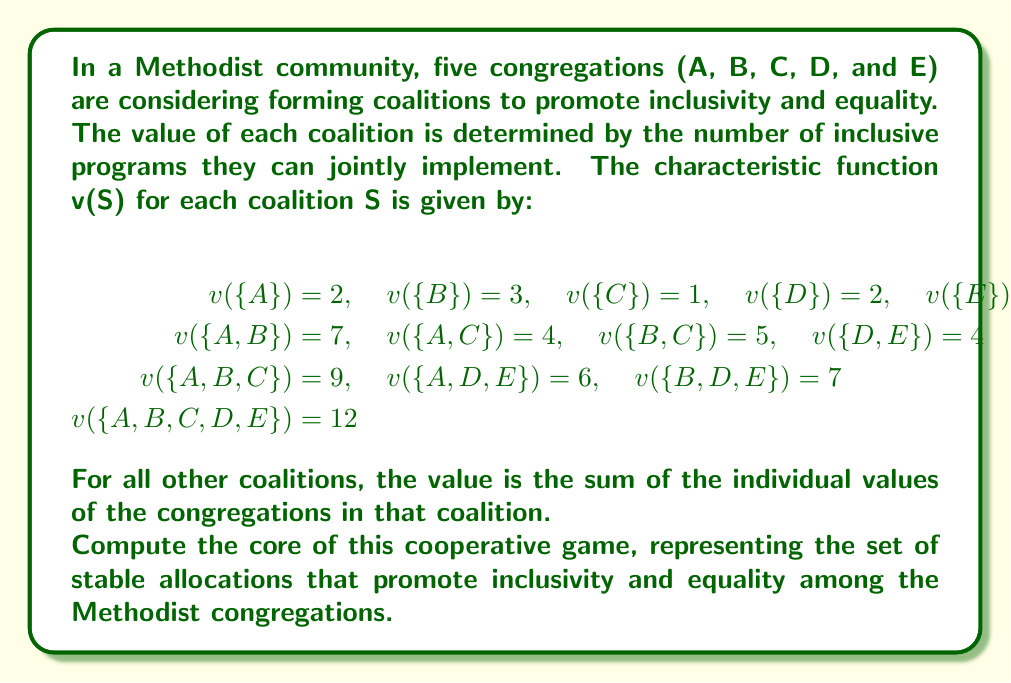Solve this math problem. To find the core of this cooperative game, we need to follow these steps:

1) First, let's define the core. The core is the set of allocations (x_A, x_B, x_C, x_D, x_E) that satisfy:

   a) Efficiency: $x_A + x_B + x_C + x_D + x_E = v(\{A,B,C,D,E\}) = 12$
   b) Individual rationality: $x_A \geq 2, x_B \geq 3, x_C \geq 1, x_D \geq 2, x_E \geq 1$
   c) Coalition rationality: For any coalition S, $\sum_{i \in S} x_i \geq v(S)$

2) We can set up the inequalities based on the coalition values:

   $x_A + x_B \geq 7$
   $x_A + x_C \geq 4$
   $x_B + x_C \geq 5$
   $x_D + x_E \geq 4$
   $x_A + x_B + x_C \geq 9$
   $x_A + x_D + x_E \geq 6$
   $x_B + x_D + x_E \geq 7$

3) Combining these with the efficiency and individual rationality conditions, we get a system of linear inequalities:

   $x_A + x_B + x_C + x_D + x_E = 12$
   $x_A \geq 2, x_B \geq 3, x_C \geq 1, x_D \geq 2, x_E \geq 1$
   $x_A + x_B \geq 7$
   $x_A + x_C \geq 4$
   $x_B + x_C \geq 5$
   $x_D + x_E \geq 4$
   $x_A + x_B + x_C \geq 9$
   $x_A + x_D + x_E \geq 6$
   $x_B + x_D + x_E \geq 7$

4) The core is the set of all solutions to this system of inequalities. While we can't list all possible solutions, we can describe the core as this set of inequalities.

5) To verify that the core is non-empty, we can find a specific allocation that satisfies all constraints. For example:

   $x_A = 3, x_B = 4, x_C = 1, x_D = 2, x_E = 2$

   This allocation satisfies all the inequalities and sums to 12, so it's in the core.
Answer: The core is the set of allocations $(x_A, x_B, x_C, x_D, x_E)$ satisfying:
$$\begin{align*}
x_A + x_B + x_C + x_D + x_E &= 12 \\
x_A \geq 2, x_B \geq 3, x_C \geq 1, x_D \geq 2, x_E \geq 1 \\
x_A + x_B \geq 7, x_A + x_C \geq 4, x_B + x_C \geq 5 \\
x_D + x_E \geq 4, x_A + x_B + x_C \geq 9 \\
x_A + x_D + x_E \geq 6, x_B + x_D + x_E \geq 7
\end{align*}$$ 